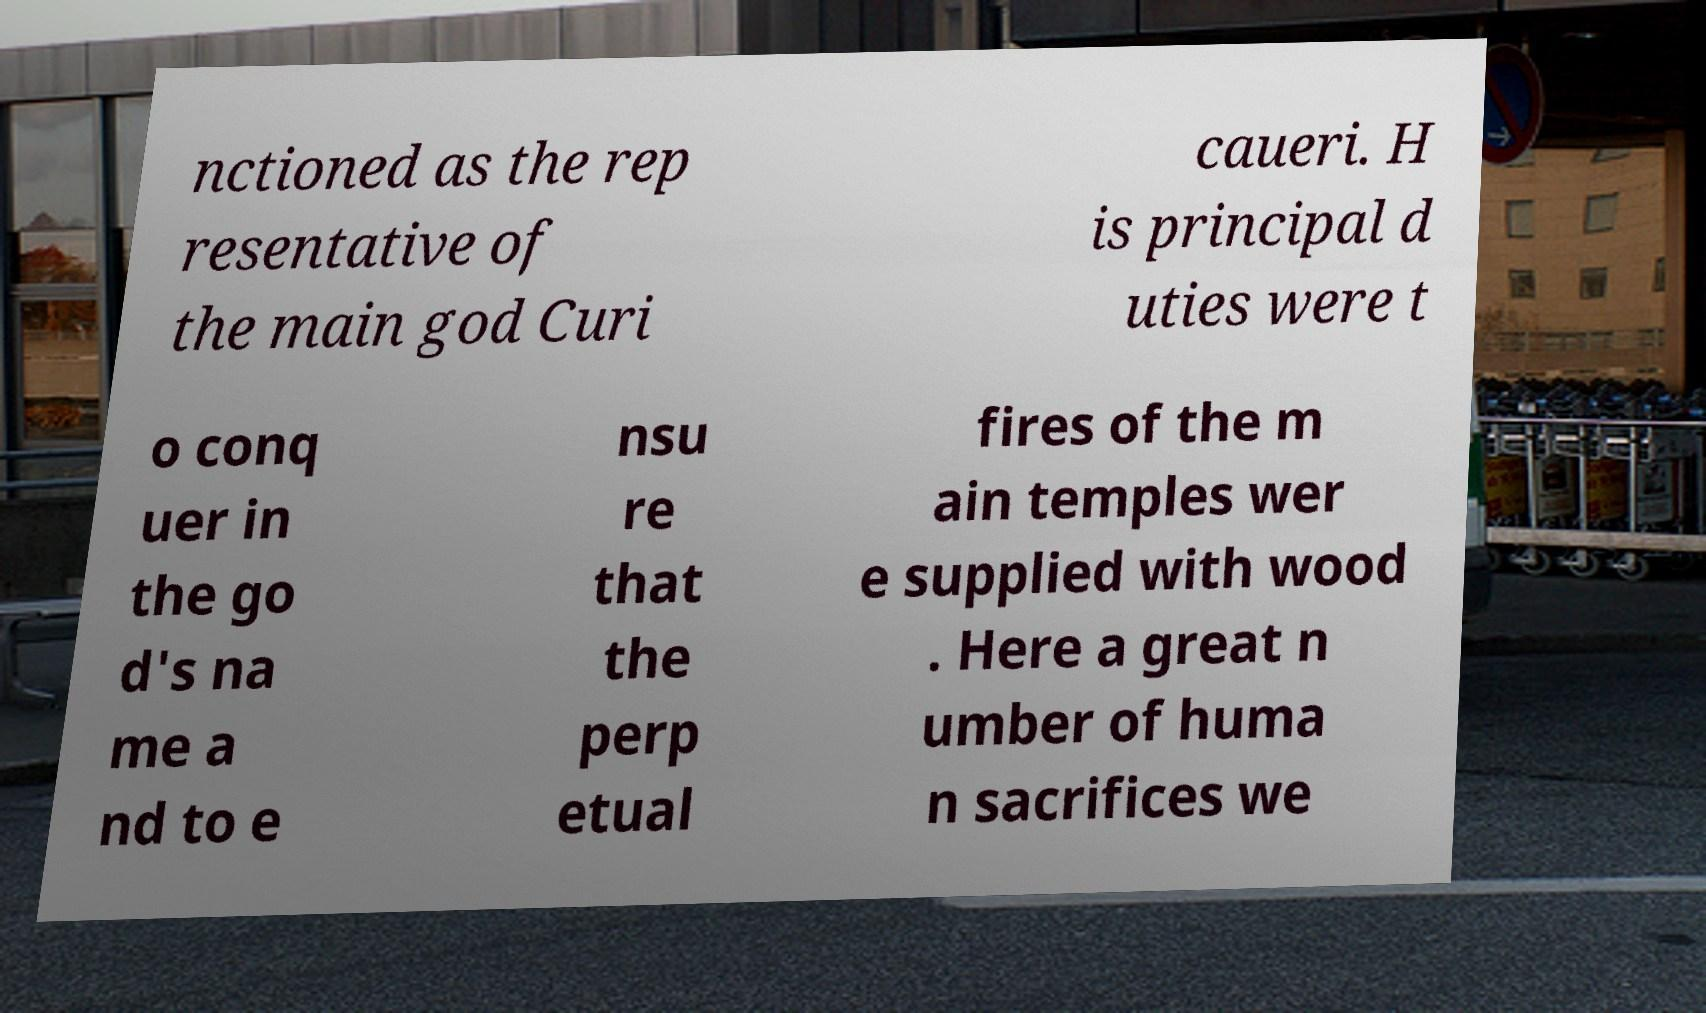What messages or text are displayed in this image? I need them in a readable, typed format. nctioned as the rep resentative of the main god Curi caueri. H is principal d uties were t o conq uer in the go d's na me a nd to e nsu re that the perp etual fires of the m ain temples wer e supplied with wood . Here a great n umber of huma n sacrifices we 